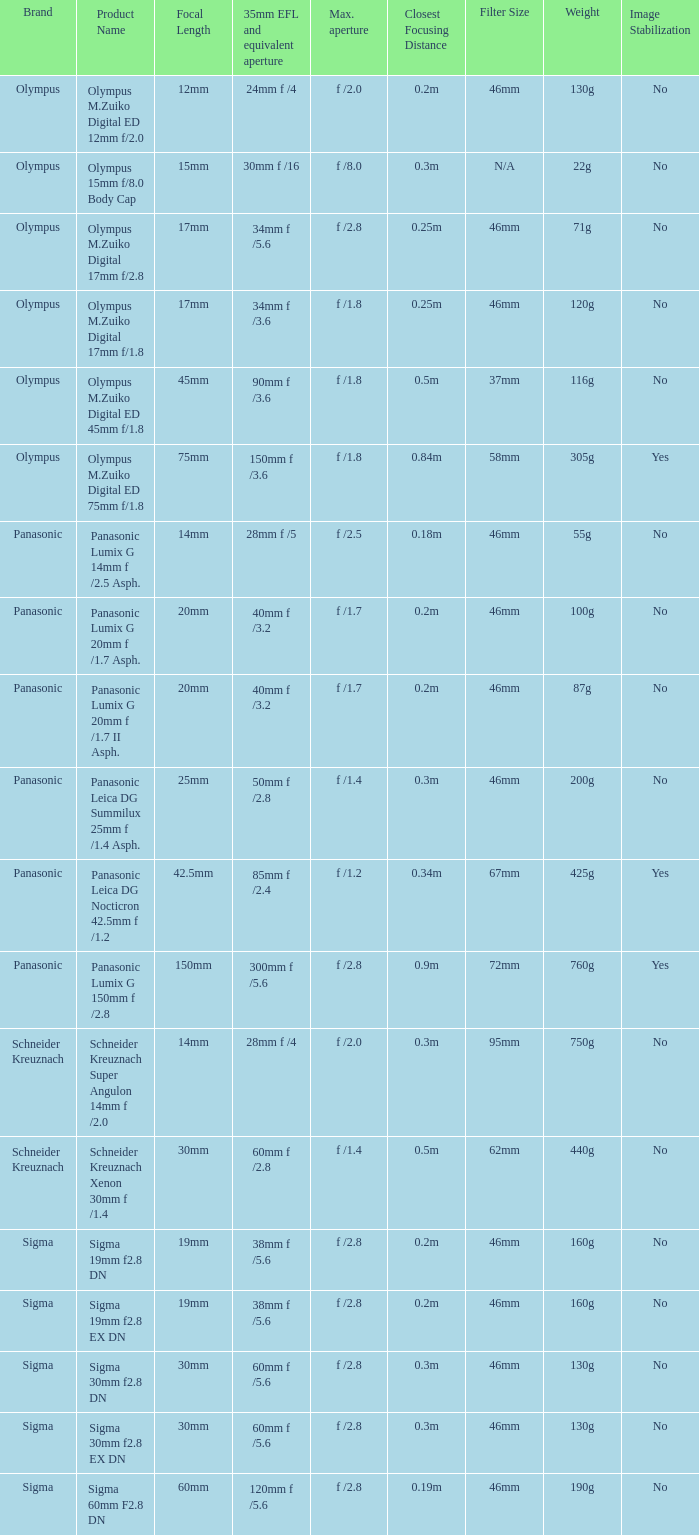What is the 35mm EFL and the equivalent aperture of the lens(es) with a maximum aperture of f /2.5? 28mm f /5. 